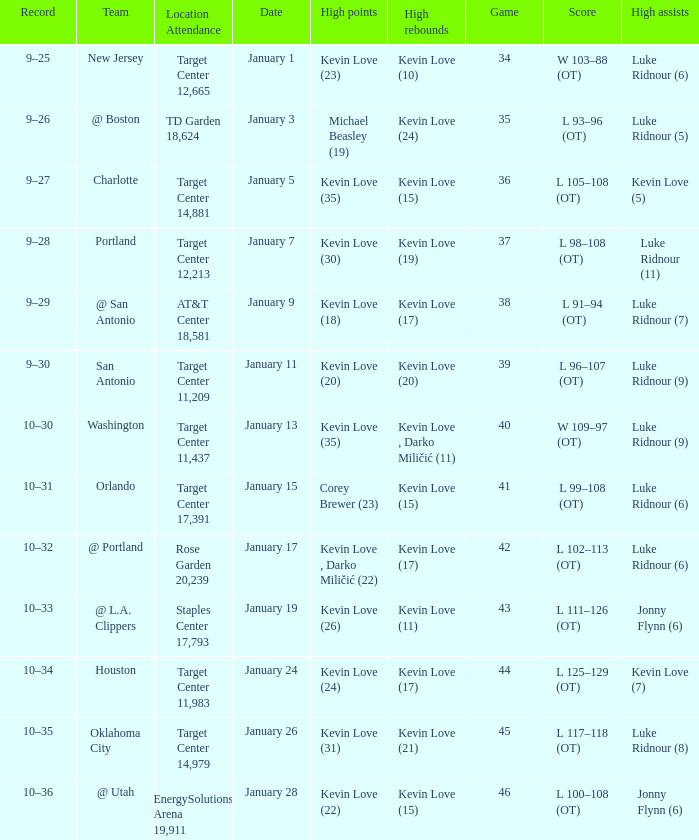What is the date for the game 35? January 3. 